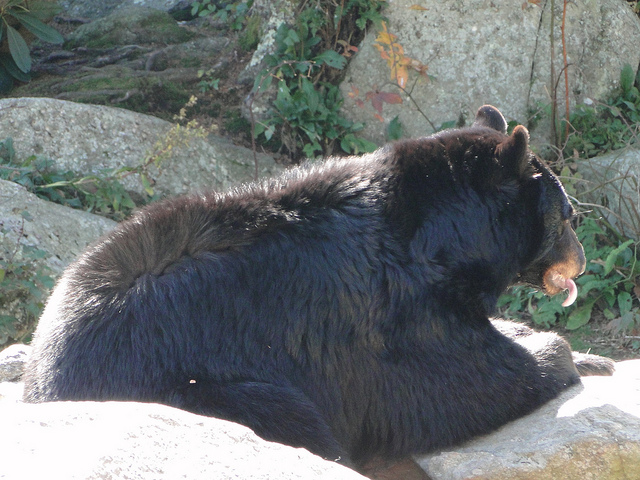<image>How old is the bear? It is ambiguous how old the bear is. How old is the bear? I don't know how old the bear is. It can be anywhere from 2 to 12 years old or even older. 